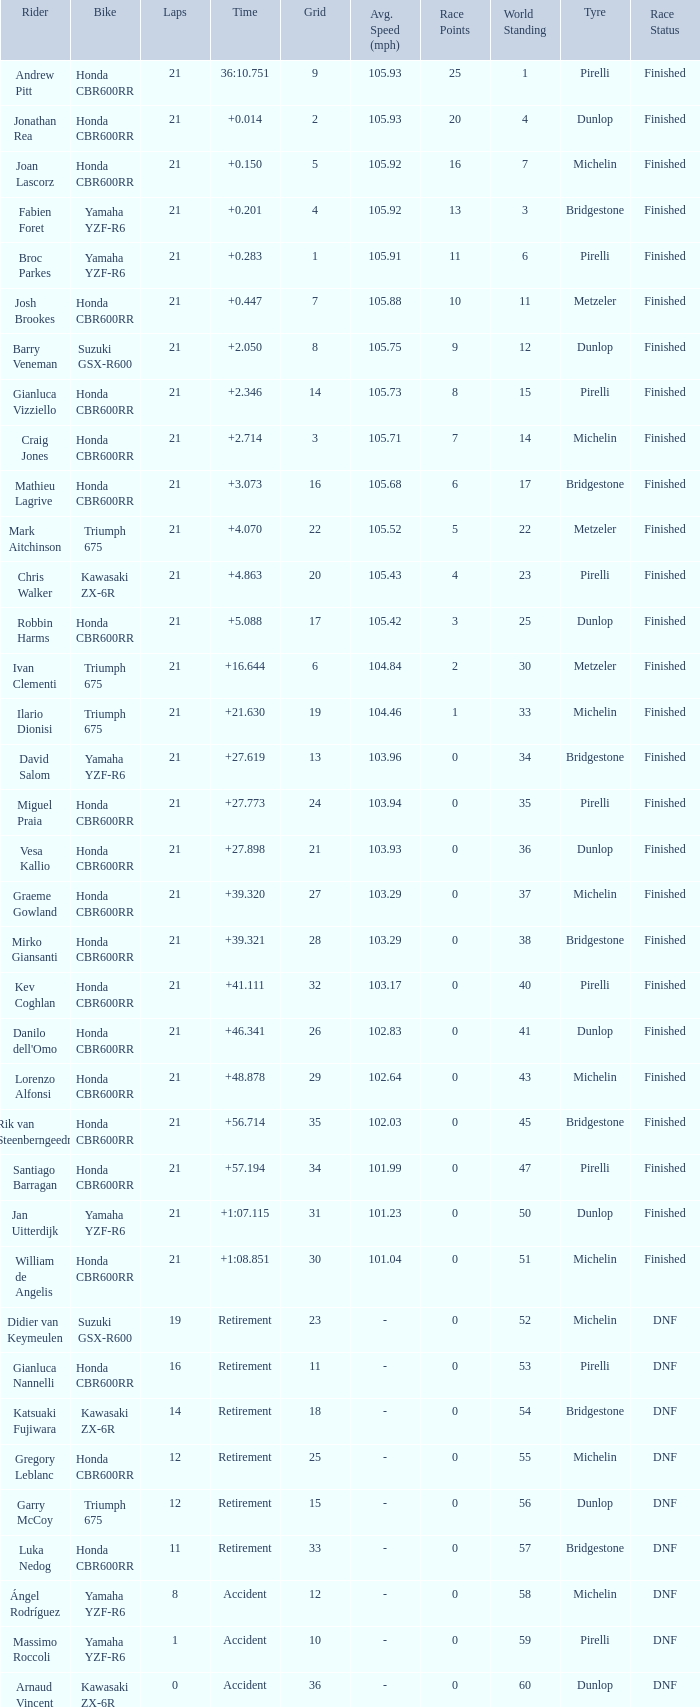What is the driver with the laps under 16, grid of 10, a bike of Yamaha YZF-R6, and ended with an accident? Massimo Roccoli. 